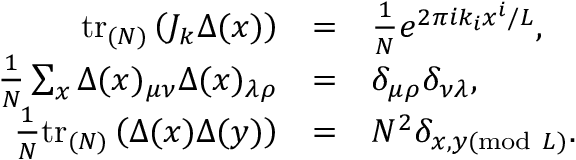Convert formula to latex. <formula><loc_0><loc_0><loc_500><loc_500>\begin{array} { r c l } { { t r _ { ( N ) } \left ( J _ { k } \Delta ( x ) \right ) } } & { = } & { { \frac { 1 } { N } e ^ { 2 \pi i k _ { i } x ^ { i } / L } , } } \\ { { \frac { 1 } { N } \sum _ { x } \Delta ( x ) _ { \mu \nu } \Delta ( x ) _ { \lambda \rho } } } & { = } & { { \delta _ { \mu \rho } \delta _ { \nu \lambda } , } } \\ { { \frac { 1 } { N } t r _ { ( N ) } \left ( \Delta ( x ) \Delta ( y ) \right ) } } & { = } & { { N ^ { 2 } \delta _ { x , y ( m o d \ L ) } . } } \end{array}</formula> 